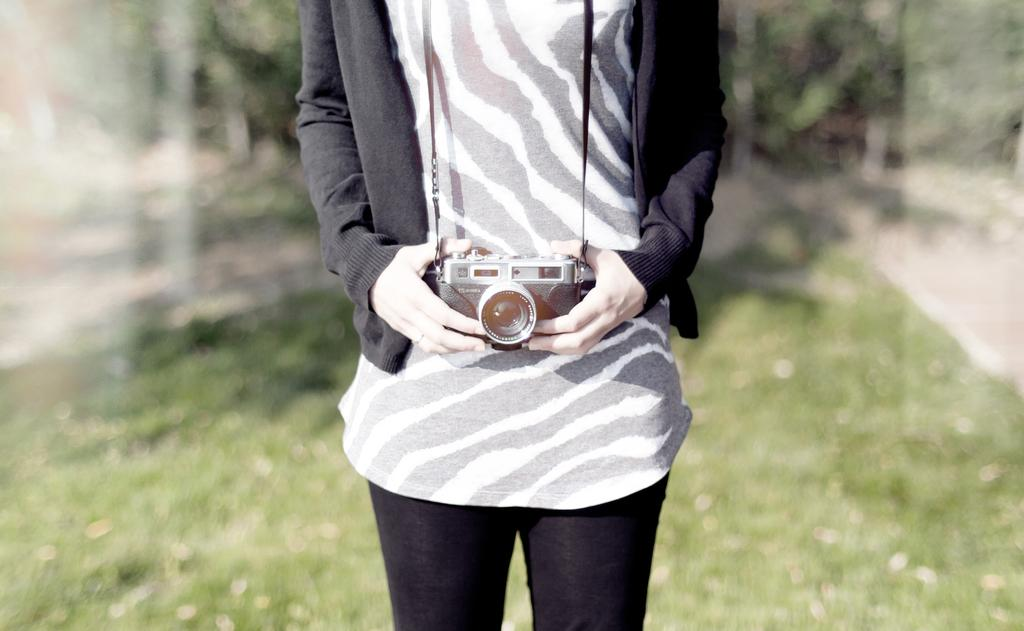What is the main subject of the image? There is a person in the image. What is the person holding in the image? The person is holding a camera. Can you describe the background of the image? The background of the image is blurry. What type of operation is being performed in the wilderness in the image? There is no operation or wilderness present in the image; it features a person holding a camera with a blurry background. 